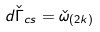Convert formula to latex. <formula><loc_0><loc_0><loc_500><loc_500>d \check { \Gamma } _ { c s } = \check { \omega } _ { ( 2 k ) }</formula> 